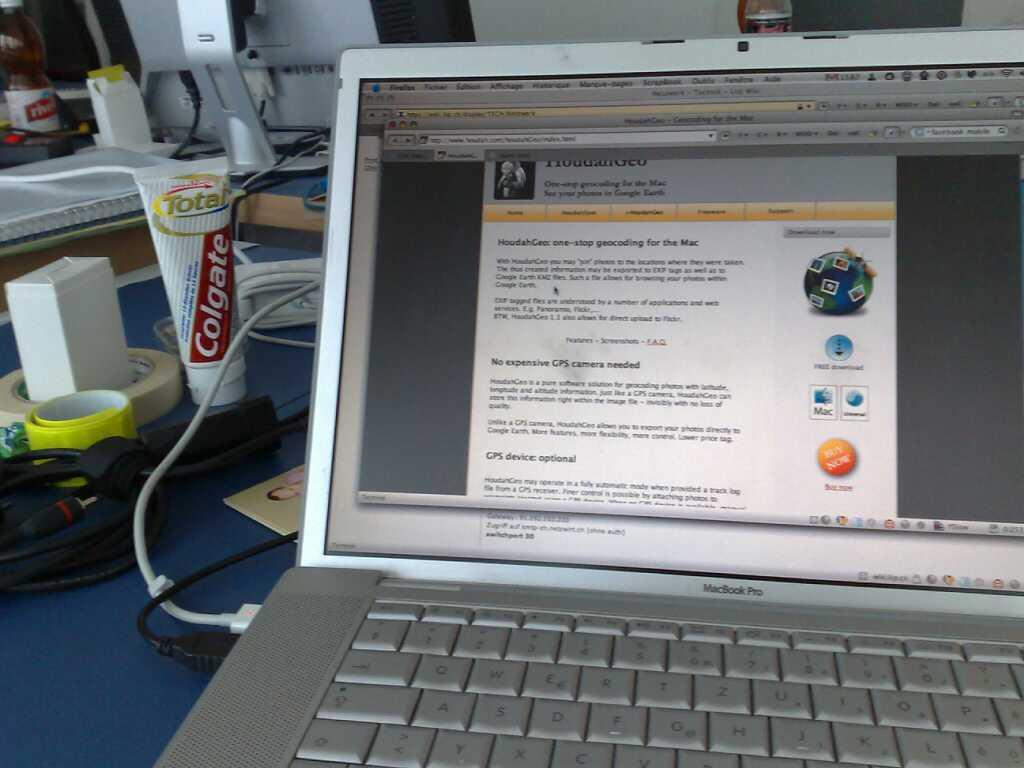Provide a one-sentence caption for the provided image. A tube of colgate toothpaste sits on a desk with a laptop. 